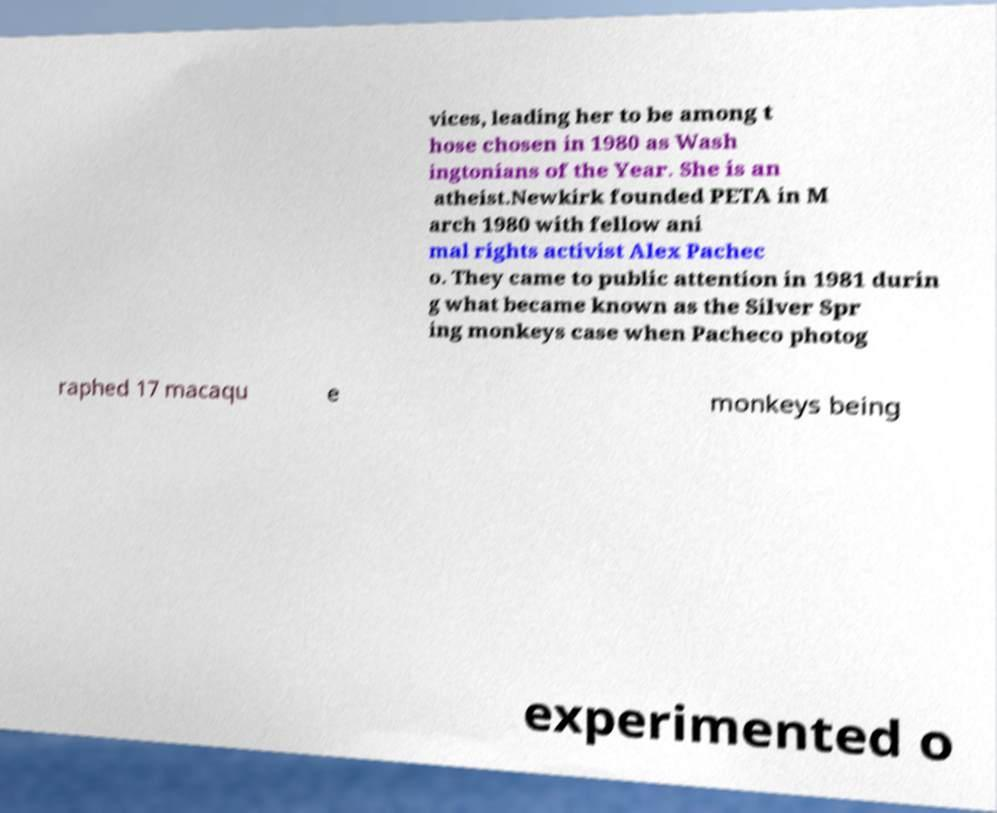Could you extract and type out the text from this image? vices, leading her to be among t hose chosen in 1980 as Wash ingtonians of the Year. She is an atheist.Newkirk founded PETA in M arch 1980 with fellow ani mal rights activist Alex Pachec o. They came to public attention in 1981 durin g what became known as the Silver Spr ing monkeys case when Pacheco photog raphed 17 macaqu e monkeys being experimented o 